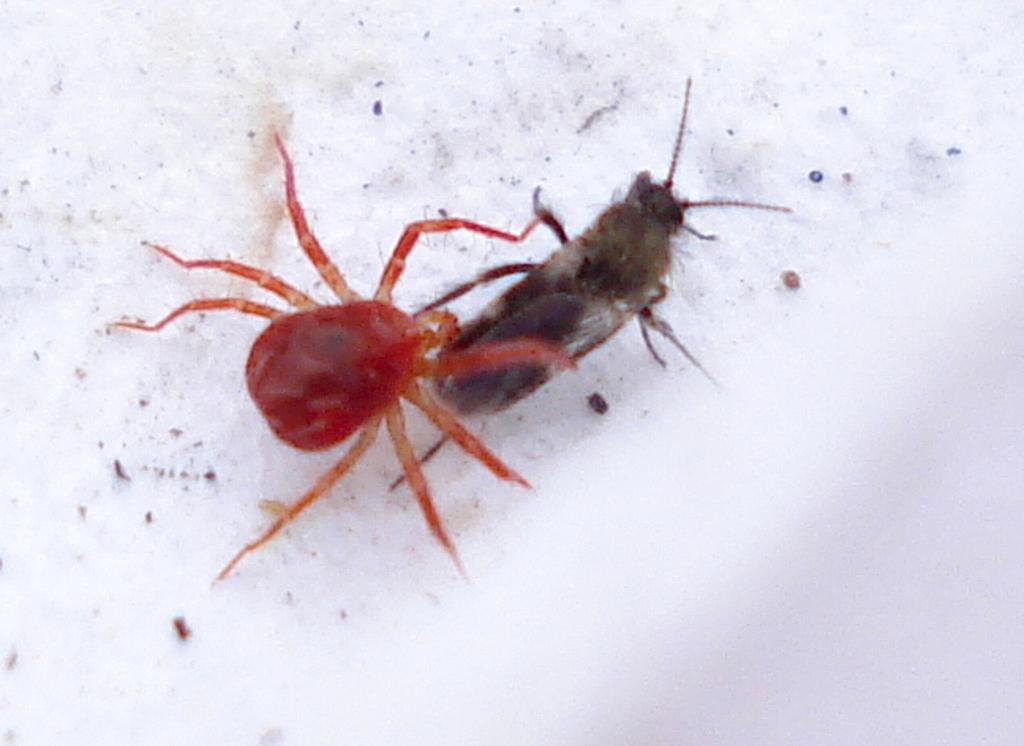What type of creature can be seen in the image? There is an insect present in the image. Where is the insect located in the image? The insect is on the floor. What type of meat is being served at the cemetery in the image? There is no meat or cemetery present in the image; it only features an insect on the floor. 